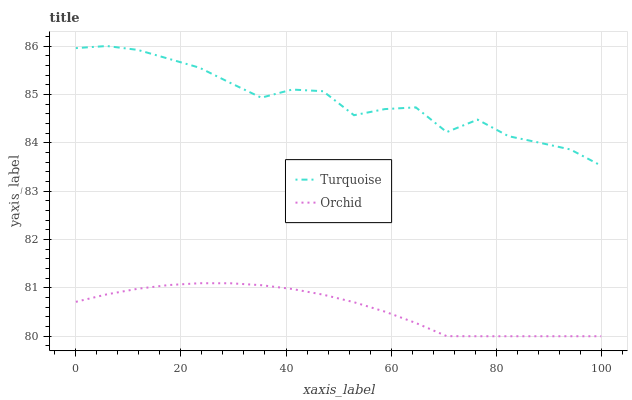Does Orchid have the minimum area under the curve?
Answer yes or no. Yes. Does Turquoise have the maximum area under the curve?
Answer yes or no. Yes. Does Orchid have the maximum area under the curve?
Answer yes or no. No. Is Orchid the smoothest?
Answer yes or no. Yes. Is Turquoise the roughest?
Answer yes or no. Yes. Is Orchid the roughest?
Answer yes or no. No. Does Orchid have the lowest value?
Answer yes or no. Yes. Does Turquoise have the highest value?
Answer yes or no. Yes. Does Orchid have the highest value?
Answer yes or no. No. Is Orchid less than Turquoise?
Answer yes or no. Yes. Is Turquoise greater than Orchid?
Answer yes or no. Yes. Does Orchid intersect Turquoise?
Answer yes or no. No. 